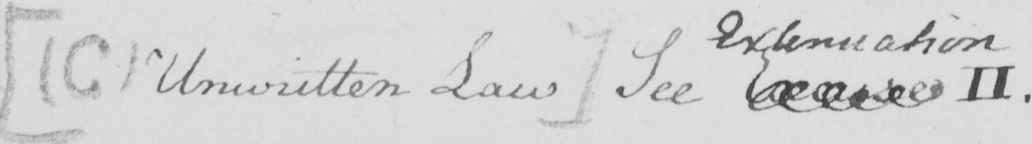Can you read and transcribe this handwriting? [  ( C )  Unwritten Law ]  See Excuse II 